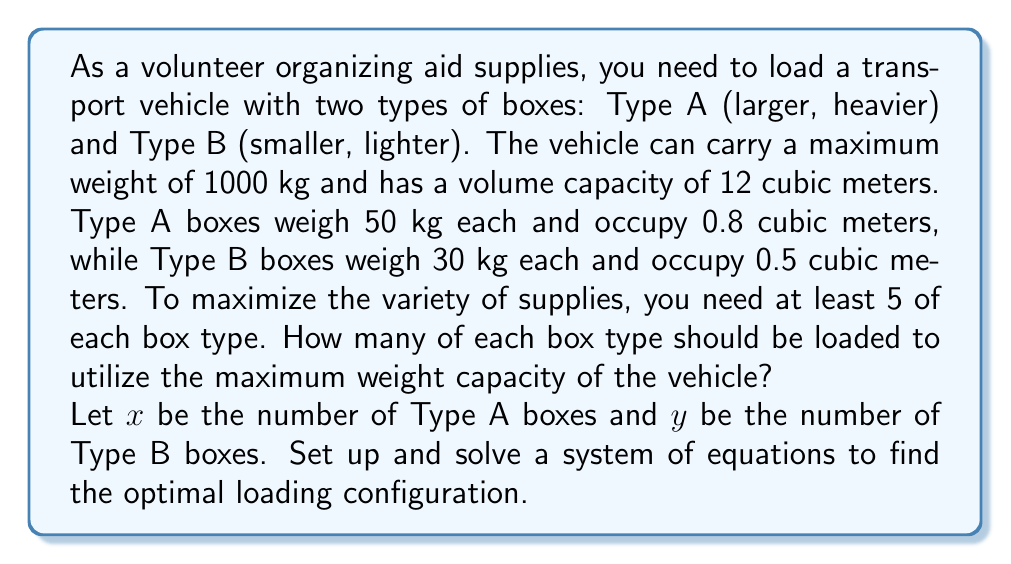Give your solution to this math problem. Let's approach this step-by-step:

1) First, we set up the weight equation:
   $$50x + 30y = 1000$$

2) Next, we set up the volume equation:
   $$0.8x + 0.5y \leq 12$$

3) We also have the constraints:
   $$x \geq 5$$ and $$y \geq 5$$

4) To maximize weight capacity utilization, we focus on the weight equation:
   $$50x + 30y = 1000$$

5) We can express $y$ in terms of $x$:
   $$y = \frac{1000 - 50x}{30} = \frac{100 - 5x}{3}$$

6) Now, we need to find the maximum integer value of $x$ that satisfies all constraints:

   a) From $x \geq 5$, we know $x$ must be at least 5.
   
   b) Substituting the expression for $y$ into $y \geq 5$:
      $$\frac{100 - 5x}{3} \geq 5$$
      $$100 - 5x \geq 15$$
      $$85 \geq 5x$$
      $$17 \geq x$$

   c) Checking the volume constraint:
      $$0.8x + 0.5(\frac{100 - 5x}{3}) \leq 12$$
      $$0.8x + \frac{50 - 2.5x}{3} \leq 12$$
      $$2.4x + 50 - 2.5x \leq 36$$
      $$50 - 0.1x \leq 36$$
      $$14 \leq x$$

7) Therefore, $x$ must be an integer between 14 and 17, inclusive.

8) Testing these values:
   For $x = 17$: $y = \frac{100 - 5(17)}{3} = 5\frac{1}{3}$ (not an integer)
   For $x = 16$: $y = \frac{100 - 5(16)}{3} = 6\frac{2}{3}$ (not an integer)
   For $x = 15$: $y = \frac{100 - 5(15)}{3} = 8\frac{1}{3}$ (not an integer)
   For $x = 14$: $y = \frac{100 - 5(14)}{3} = 10$ (an integer)

9) Therefore, the optimal solution is $x = 14$ and $y = 10$.
Answer: 14 Type A boxes and 10 Type B boxes 